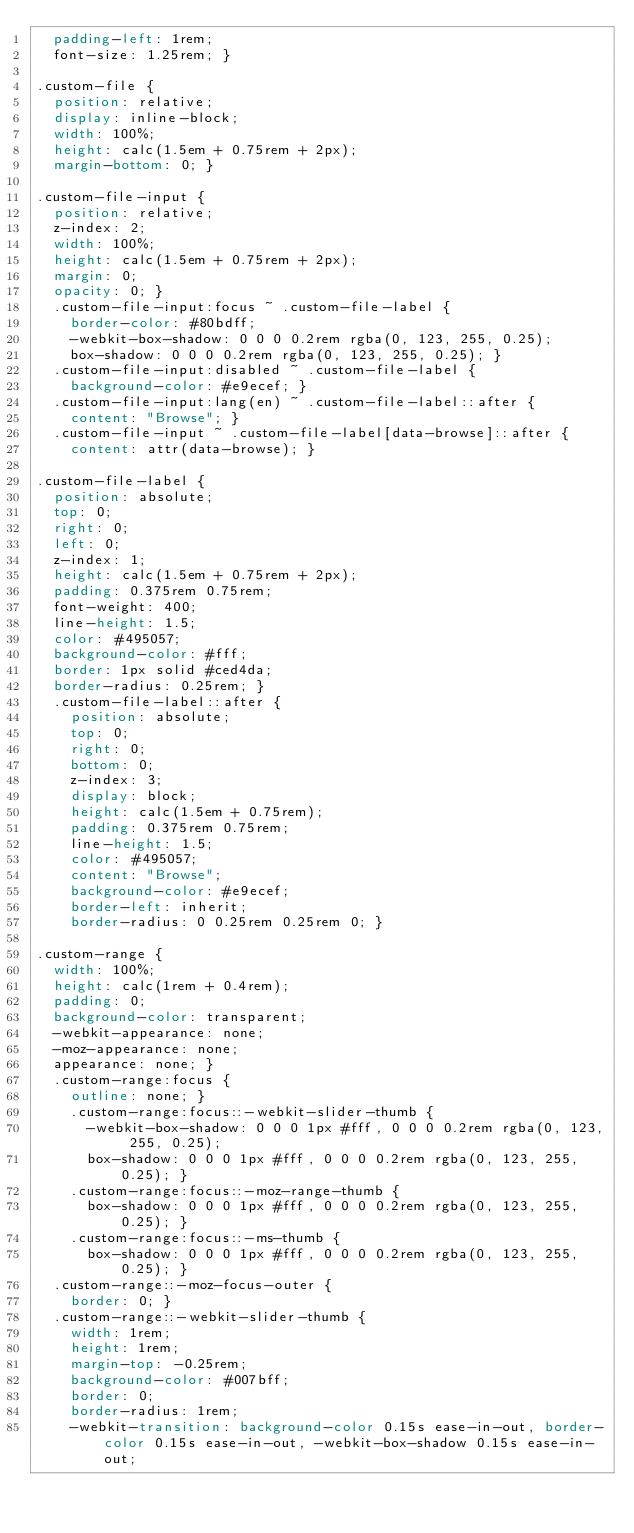<code> <loc_0><loc_0><loc_500><loc_500><_CSS_>  padding-left: 1rem;
  font-size: 1.25rem; }

.custom-file {
  position: relative;
  display: inline-block;
  width: 100%;
  height: calc(1.5em + 0.75rem + 2px);
  margin-bottom: 0; }

.custom-file-input {
  position: relative;
  z-index: 2;
  width: 100%;
  height: calc(1.5em + 0.75rem + 2px);
  margin: 0;
  opacity: 0; }
  .custom-file-input:focus ~ .custom-file-label {
    border-color: #80bdff;
    -webkit-box-shadow: 0 0 0 0.2rem rgba(0, 123, 255, 0.25);
    box-shadow: 0 0 0 0.2rem rgba(0, 123, 255, 0.25); }
  .custom-file-input:disabled ~ .custom-file-label {
    background-color: #e9ecef; }
  .custom-file-input:lang(en) ~ .custom-file-label::after {
    content: "Browse"; }
  .custom-file-input ~ .custom-file-label[data-browse]::after {
    content: attr(data-browse); }

.custom-file-label {
  position: absolute;
  top: 0;
  right: 0;
  left: 0;
  z-index: 1;
  height: calc(1.5em + 0.75rem + 2px);
  padding: 0.375rem 0.75rem;
  font-weight: 400;
  line-height: 1.5;
  color: #495057;
  background-color: #fff;
  border: 1px solid #ced4da;
  border-radius: 0.25rem; }
  .custom-file-label::after {
    position: absolute;
    top: 0;
    right: 0;
    bottom: 0;
    z-index: 3;
    display: block;
    height: calc(1.5em + 0.75rem);
    padding: 0.375rem 0.75rem;
    line-height: 1.5;
    color: #495057;
    content: "Browse";
    background-color: #e9ecef;
    border-left: inherit;
    border-radius: 0 0.25rem 0.25rem 0; }

.custom-range {
  width: 100%;
  height: calc(1rem + 0.4rem);
  padding: 0;
  background-color: transparent;
  -webkit-appearance: none;
  -moz-appearance: none;
  appearance: none; }
  .custom-range:focus {
    outline: none; }
    .custom-range:focus::-webkit-slider-thumb {
      -webkit-box-shadow: 0 0 0 1px #fff, 0 0 0 0.2rem rgba(0, 123, 255, 0.25);
      box-shadow: 0 0 0 1px #fff, 0 0 0 0.2rem rgba(0, 123, 255, 0.25); }
    .custom-range:focus::-moz-range-thumb {
      box-shadow: 0 0 0 1px #fff, 0 0 0 0.2rem rgba(0, 123, 255, 0.25); }
    .custom-range:focus::-ms-thumb {
      box-shadow: 0 0 0 1px #fff, 0 0 0 0.2rem rgba(0, 123, 255, 0.25); }
  .custom-range::-moz-focus-outer {
    border: 0; }
  .custom-range::-webkit-slider-thumb {
    width: 1rem;
    height: 1rem;
    margin-top: -0.25rem;
    background-color: #007bff;
    border: 0;
    border-radius: 1rem;
    -webkit-transition: background-color 0.15s ease-in-out, border-color 0.15s ease-in-out, -webkit-box-shadow 0.15s ease-in-out;</code> 